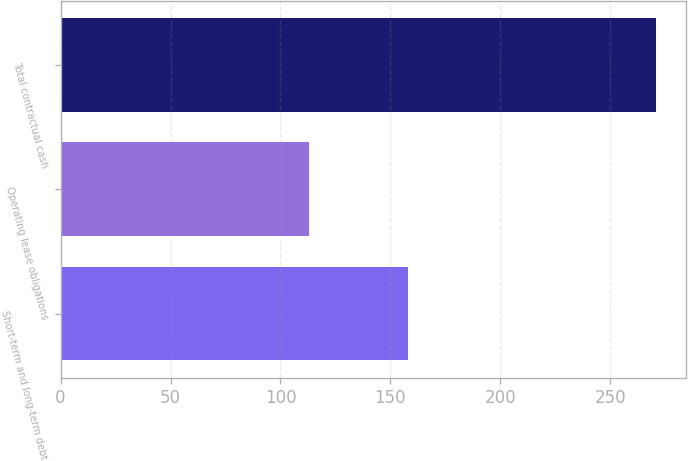Convert chart. <chart><loc_0><loc_0><loc_500><loc_500><bar_chart><fcel>Short-term and long-term debt<fcel>Operating lease obligations<fcel>Total contractual cash<nl><fcel>158<fcel>113<fcel>271<nl></chart> 